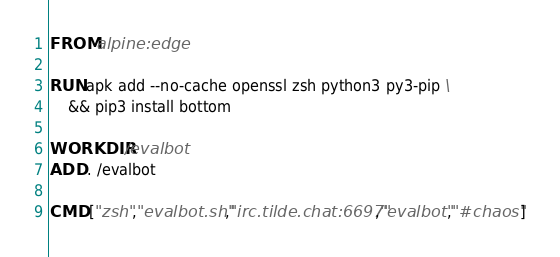<code> <loc_0><loc_0><loc_500><loc_500><_Dockerfile_>FROM alpine:edge

RUN apk add --no-cache openssl zsh python3 py3-pip \
    && pip3 install bottom

WORKDIR /evalbot
ADD . /evalbot

CMD ["zsh","evalbot.sh","irc.tilde.chat:6697","evalbot","#chaos"]
</code> 